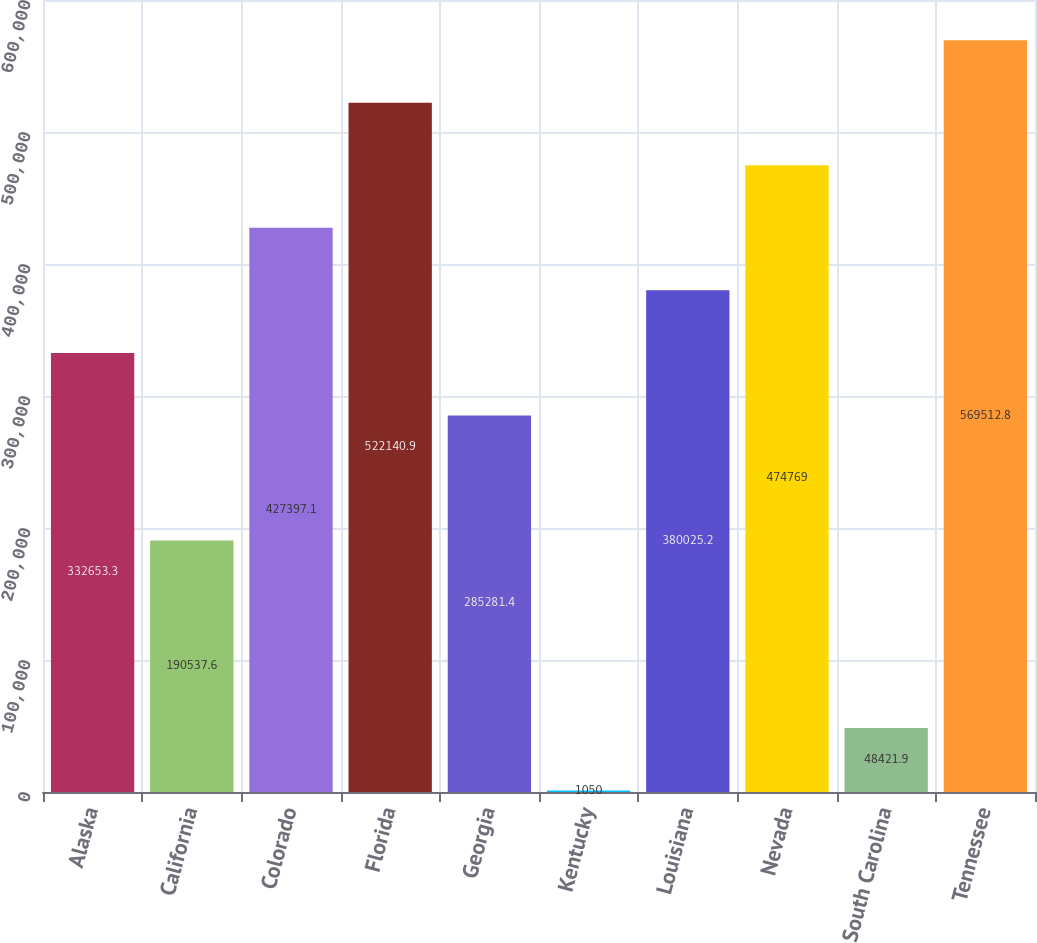Convert chart. <chart><loc_0><loc_0><loc_500><loc_500><bar_chart><fcel>Alaska<fcel>California<fcel>Colorado<fcel>Florida<fcel>Georgia<fcel>Kentucky<fcel>Louisiana<fcel>Nevada<fcel>South Carolina<fcel>Tennessee<nl><fcel>332653<fcel>190538<fcel>427397<fcel>522141<fcel>285281<fcel>1050<fcel>380025<fcel>474769<fcel>48421.9<fcel>569513<nl></chart> 